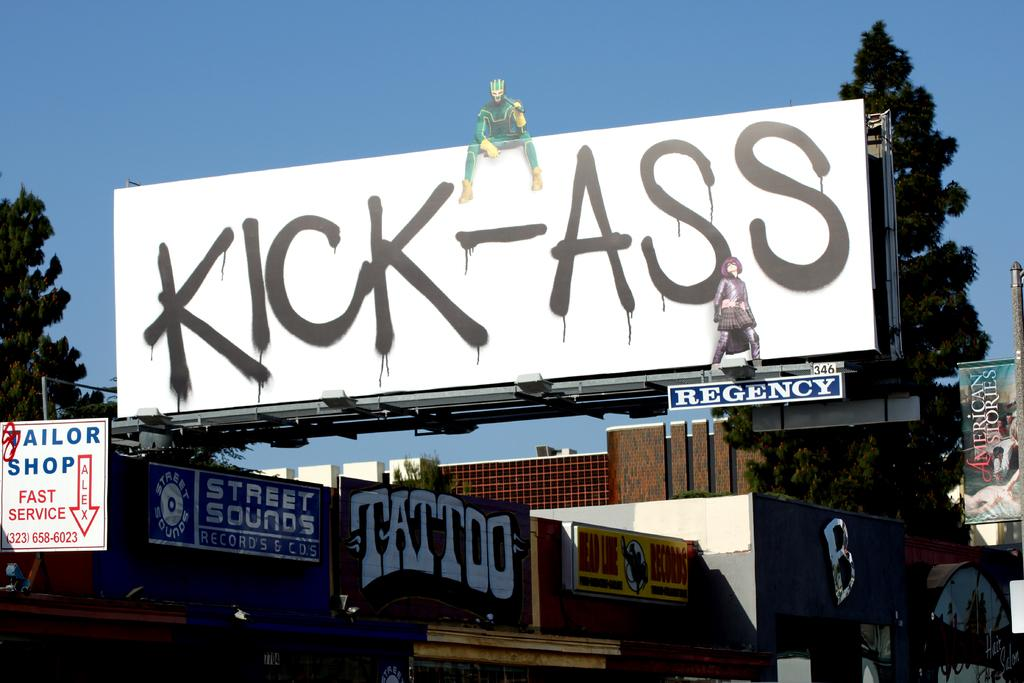<image>
Summarize the visual content of the image. The building houses a tailor shop, tattoo parlor, and a record store. 